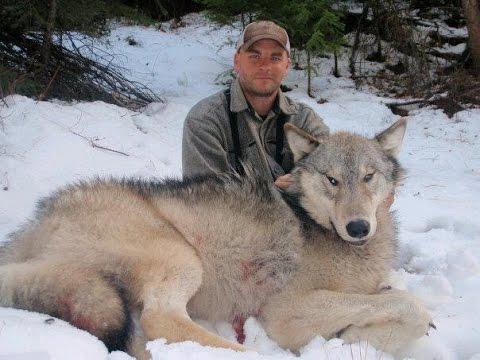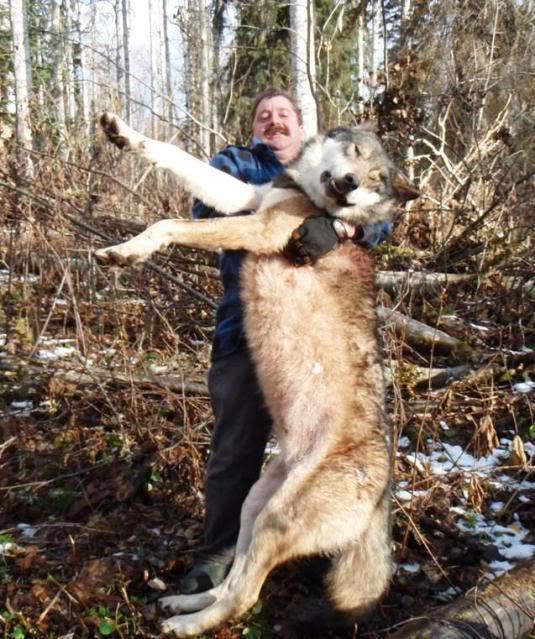The first image is the image on the left, the second image is the image on the right. Given the left and right images, does the statement "One image shows a nonstanding person posed behind a reclining wolf, and the other other image shows a standing person with arms holding up a wolf." hold true? Answer yes or no. Yes. The first image is the image on the left, the second image is the image on the right. For the images shown, is this caption "Both images contain a hunter posing with a dead wolf." true? Answer yes or no. Yes. 